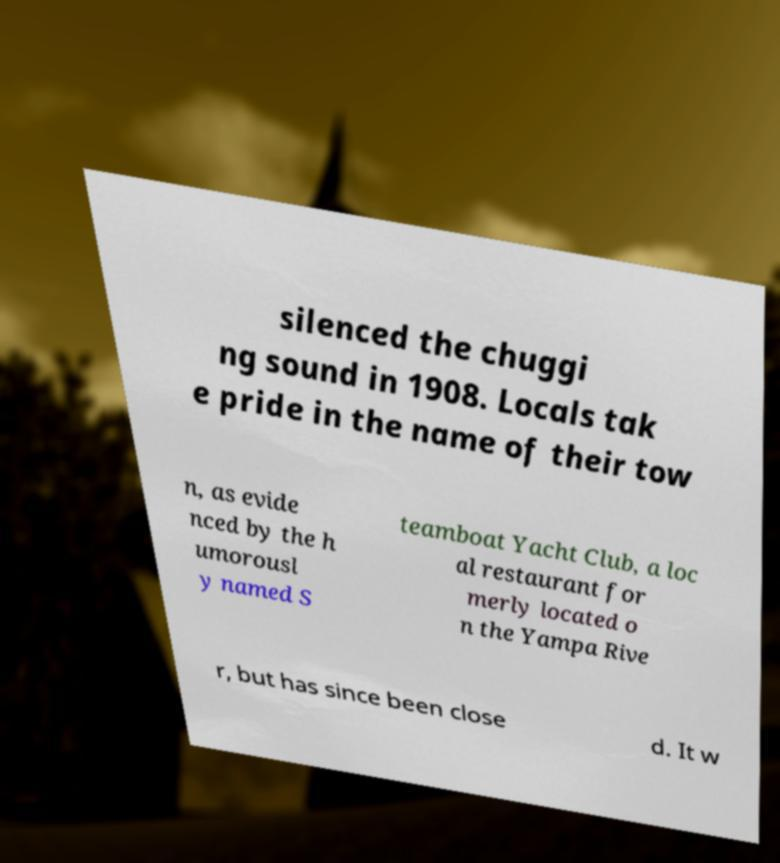Please identify and transcribe the text found in this image. silenced the chuggi ng sound in 1908. Locals tak e pride in the name of their tow n, as evide nced by the h umorousl y named S teamboat Yacht Club, a loc al restaurant for merly located o n the Yampa Rive r, but has since been close d. It w 